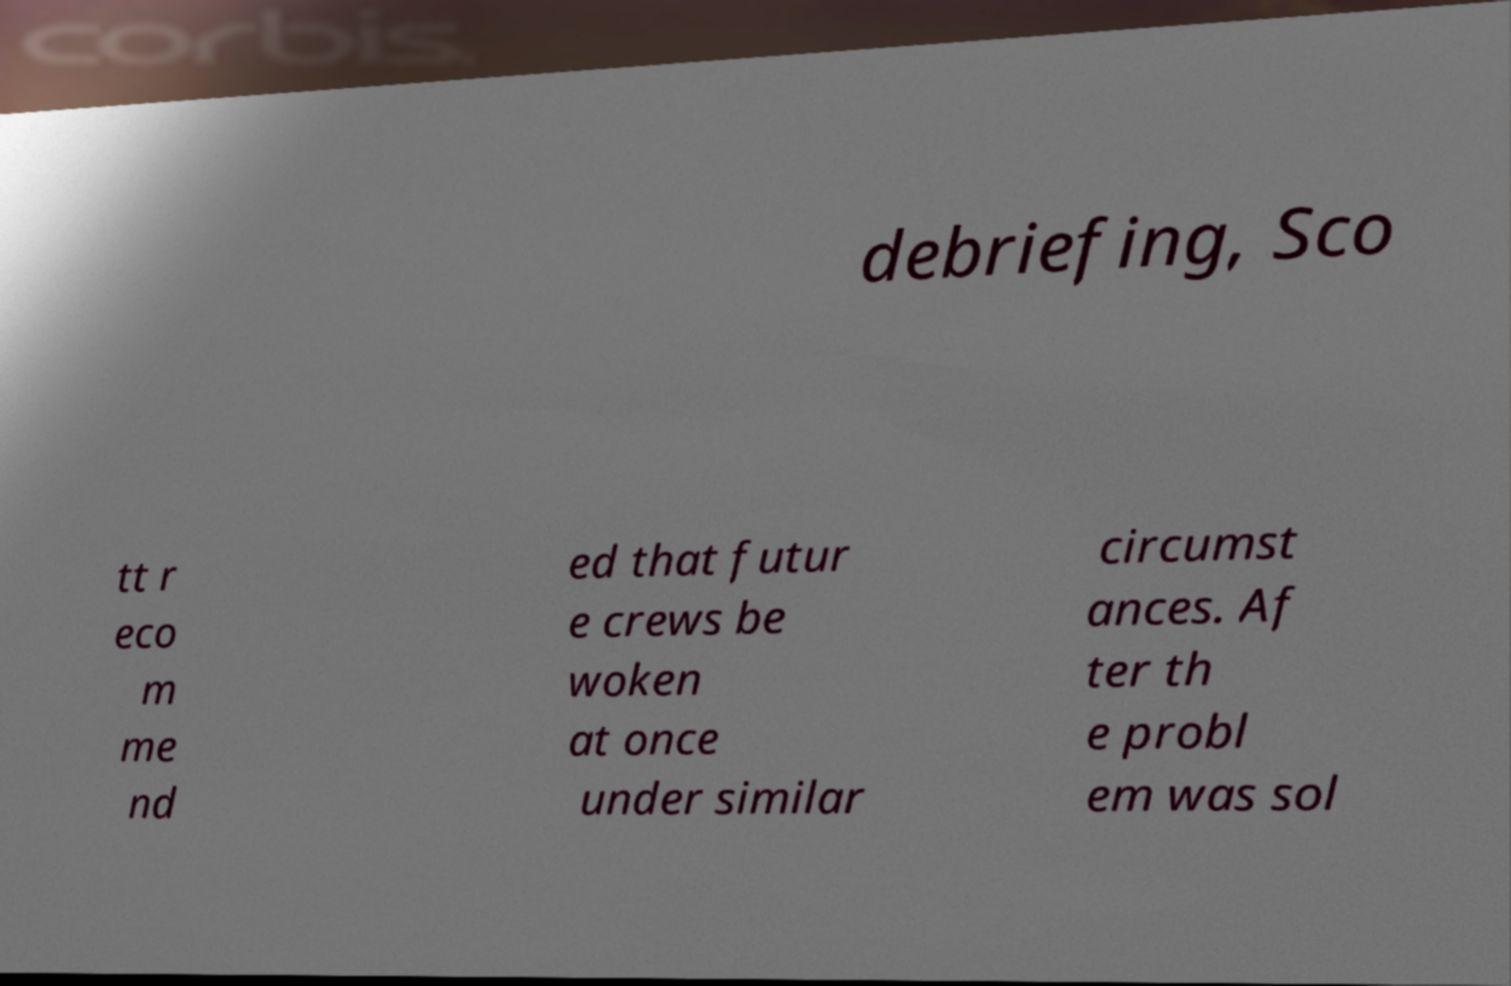Could you assist in decoding the text presented in this image and type it out clearly? debriefing, Sco tt r eco m me nd ed that futur e crews be woken at once under similar circumst ances. Af ter th e probl em was sol 